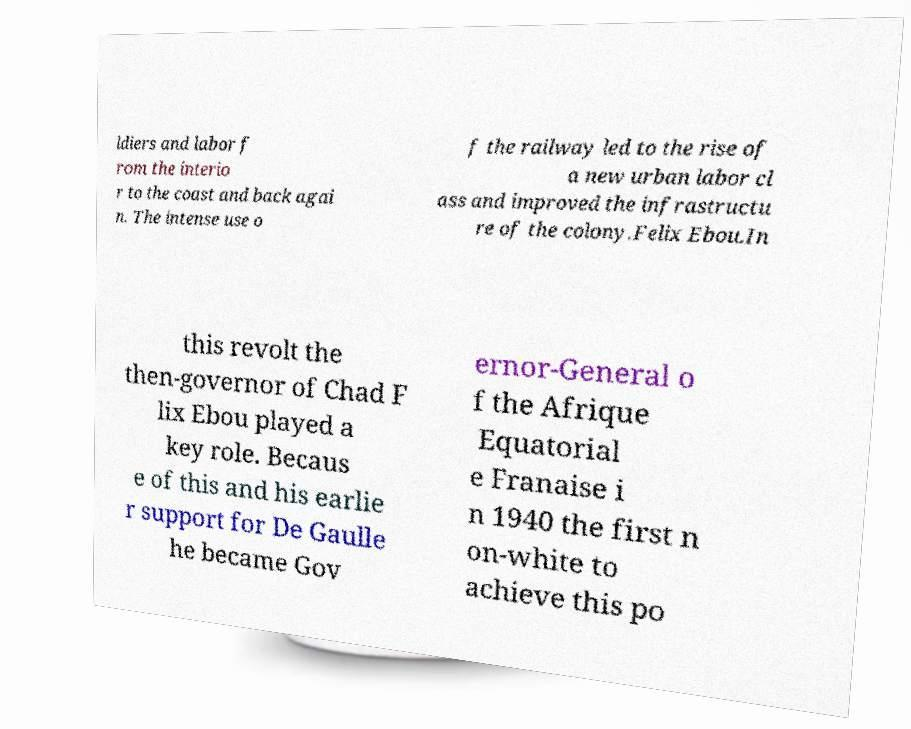For documentation purposes, I need the text within this image transcribed. Could you provide that? ldiers and labor f rom the interio r to the coast and back agai n. The intense use o f the railway led to the rise of a new urban labor cl ass and improved the infrastructu re of the colony.Felix Ebou.In this revolt the then-governor of Chad F lix Ebou played a key role. Becaus e of this and his earlie r support for De Gaulle he became Gov ernor-General o f the Afrique Equatorial e Franaise i n 1940 the first n on-white to achieve this po 